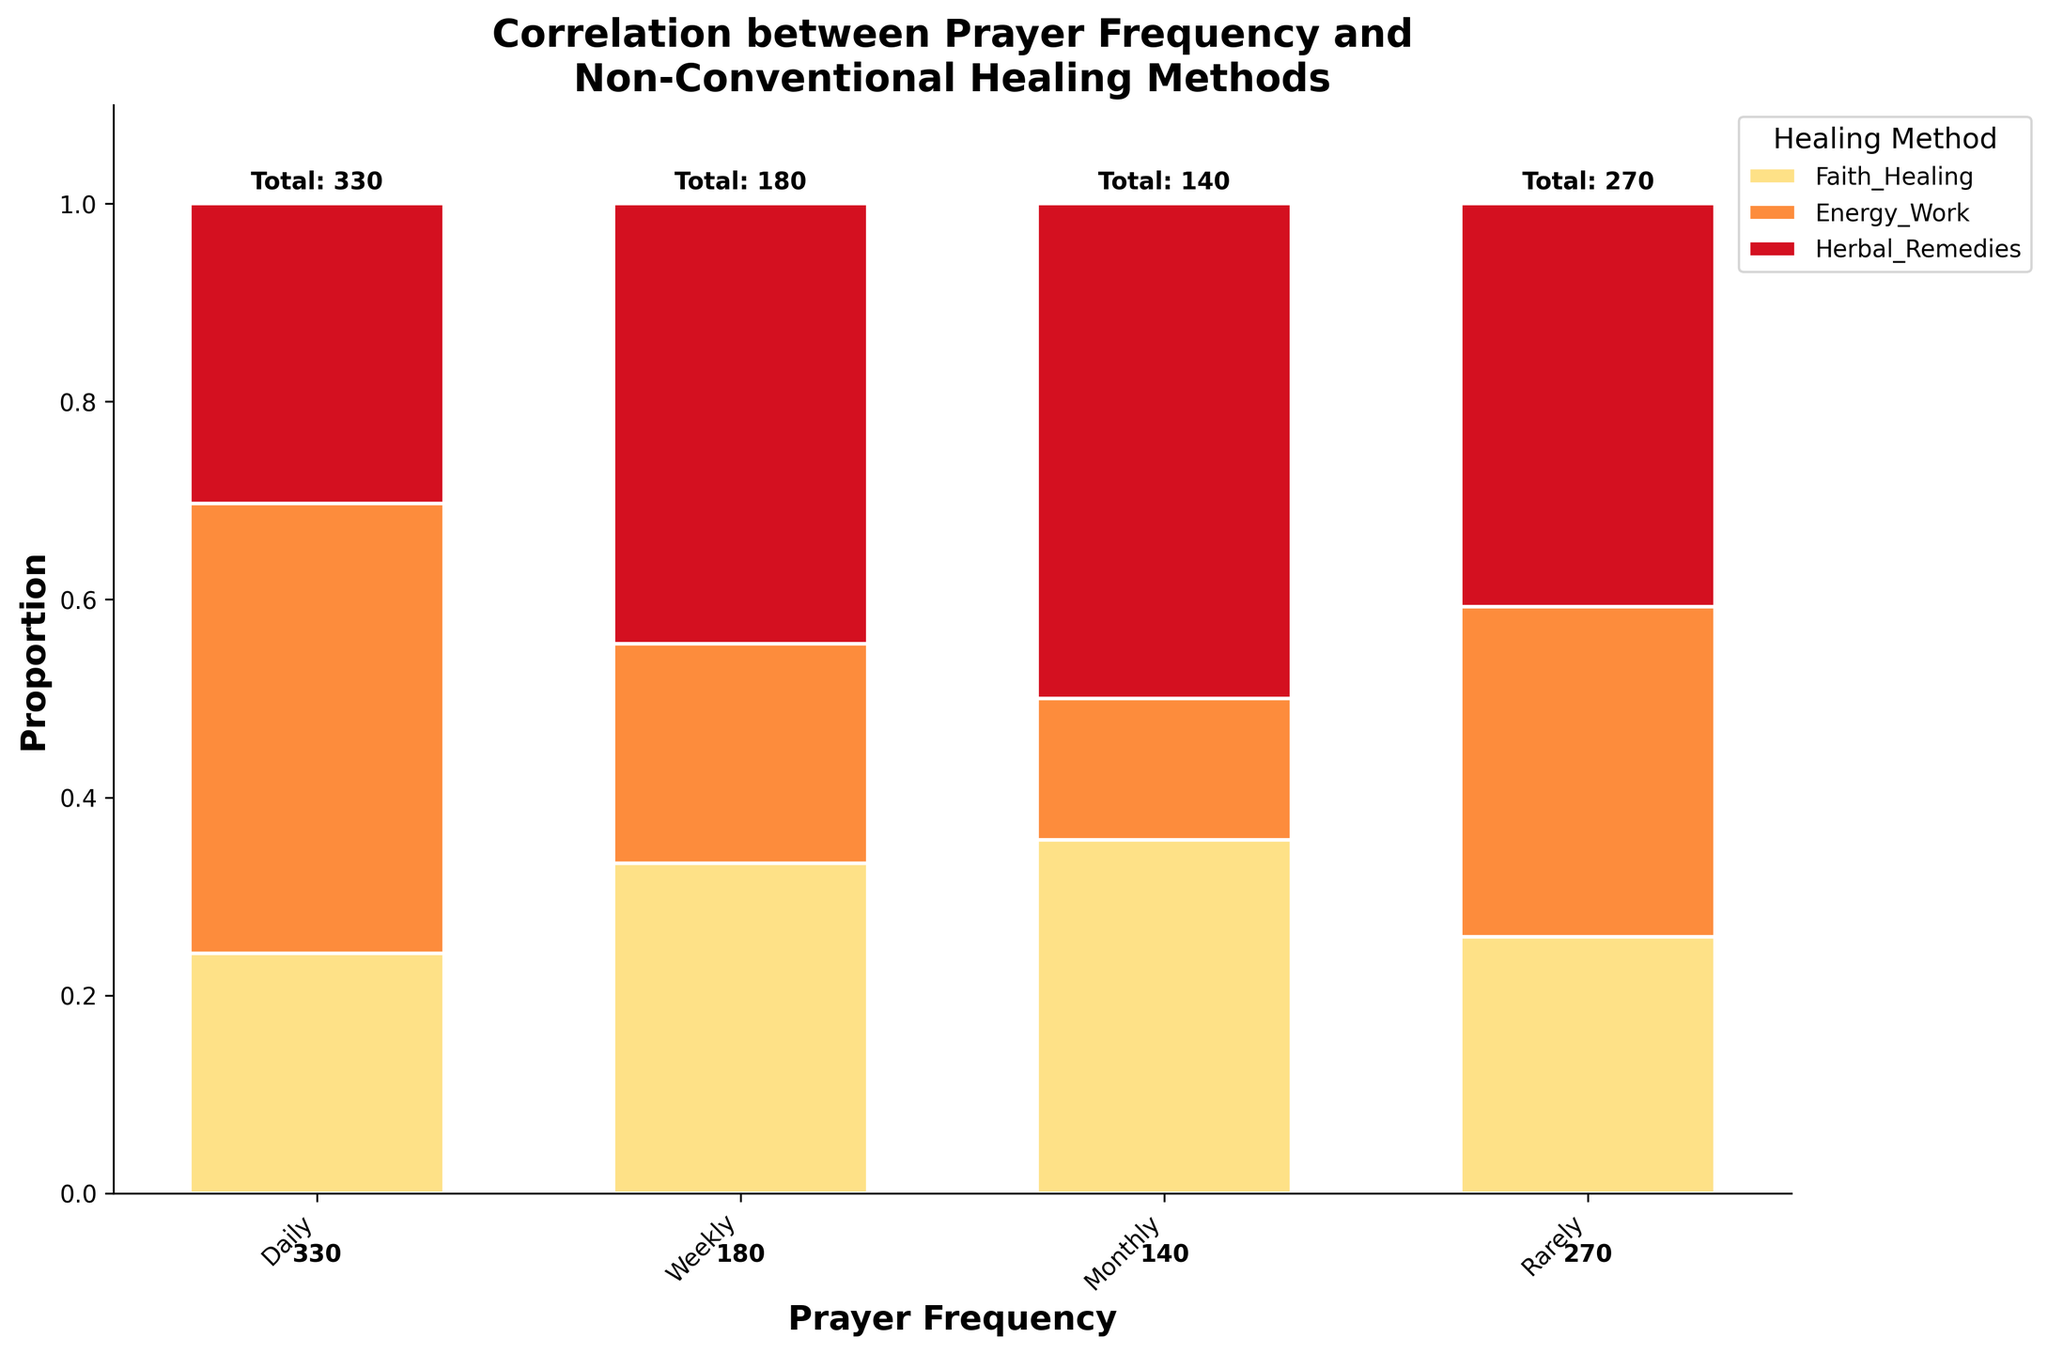How many times is "herbal remedies" chosen by those who pray daily? The Mosaic Plot shows the segments where each non-conventional healing method is used in each prayer frequency category. We look at the section for "daily prayer frequency" and find "herbal remedies" to count them visually.
Answer: 100 Which healing method is least chosen among those who pray weekly? The Mosaic Plot displays the proportional representation of each healing method within each prayer frequency category. For "weekly prayer frequency", visually identify the smallest segment.
Answer: Energy Work What is the total number of people who pray monthly? The total number of people within each prayer frequency is mentioned above the respective bar. For "monthly prayer frequency", we find the total.
Answer: 180 Is there a trend in the adoption of faith healing relative to prayer frequency? Examine the proportional sections representing "Faith Healing" across different prayer frequencies. We see larger sections in "Daily" and progressively smaller sections towards "Rarely".
Answer: Higher frequency associates with more Faith Healing How does the proportion of people using energy work compare between those who pray daily and those who pray rarely? Compare the height of the "Energy Work" segments within "daily" and "rarely" categories to assess relative proportions.
Answer: Higher in daily than rarely What percentage of those who pray weekly use herbal remedies? Divide the number of people using herbal remedies in the "weekly" group by the total number in the "weekly" group and multiply by 100. Visually, this can be approximated from the Mosaic Plot.
Answer: ~37.9% Are there more people using non-conventional methods who pray rarely or monthly? Compare the total numbers indicated for "rarely" and "monthly" categories directly from the plot.
Answer: Monthly What is the largest healing method proportion for those who pray rarely? For "rarely pray" frequency, identify which segment takes up the largest proportion visually, denoted by the height.
Answer: Herbal Remedies How many more people use faith healing than energy work among those who pray daily? Look at the counts or segment sizes for both "Faith Healing" and "Energy Work" within the "daily prayer frequency" category and subtract.
Answer: 70 Which prayer frequency group has the smallest total number of adopters of non-conventional healing methods? Totals are displayed above each bar. The smallest total can be identified directly.
Answer: Rarely 